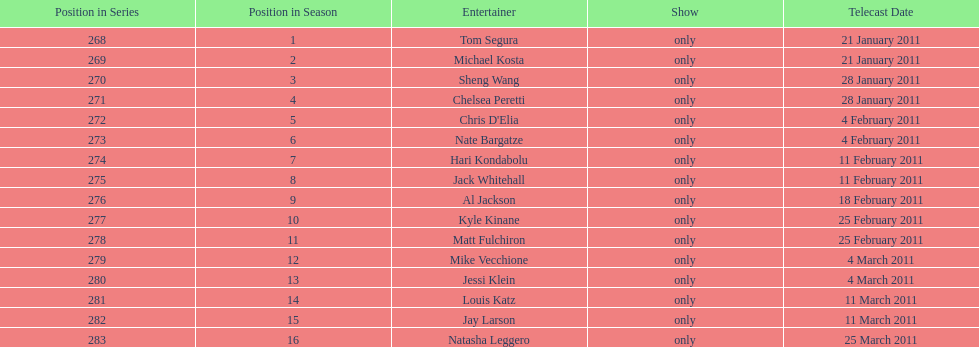How many performers appeared on the air date 21 january 2011? 2. 